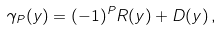Convert formula to latex. <formula><loc_0><loc_0><loc_500><loc_500>\gamma _ { P } ( y ) = ( - 1 ) ^ { P } R ( y ) + D ( y ) \, ,</formula> 